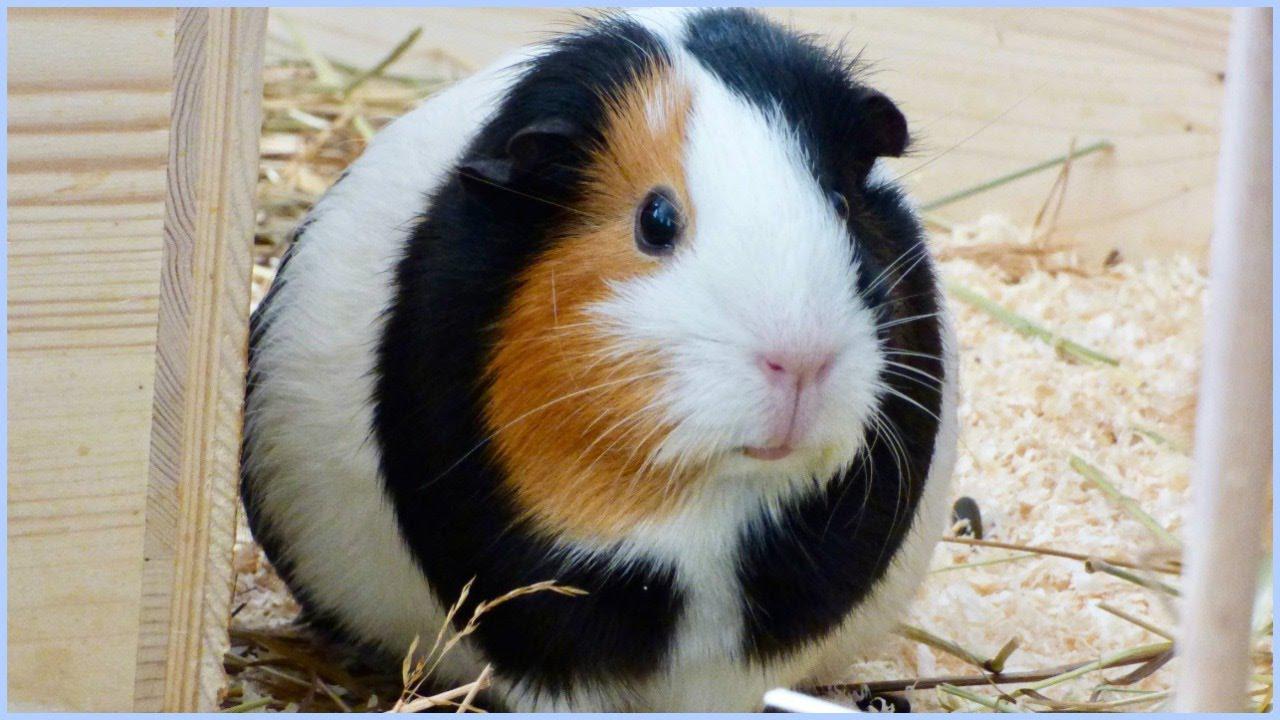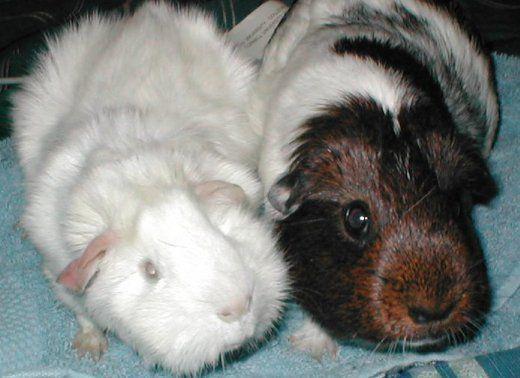The first image is the image on the left, the second image is the image on the right. Assess this claim about the two images: "There are three hamsters in total.". Correct or not? Answer yes or no. Yes. The first image is the image on the left, the second image is the image on the right. Considering the images on both sides, is "In total, three guinea pigs are shown, and the right image contains more animals than the left image." valid? Answer yes or no. Yes. 